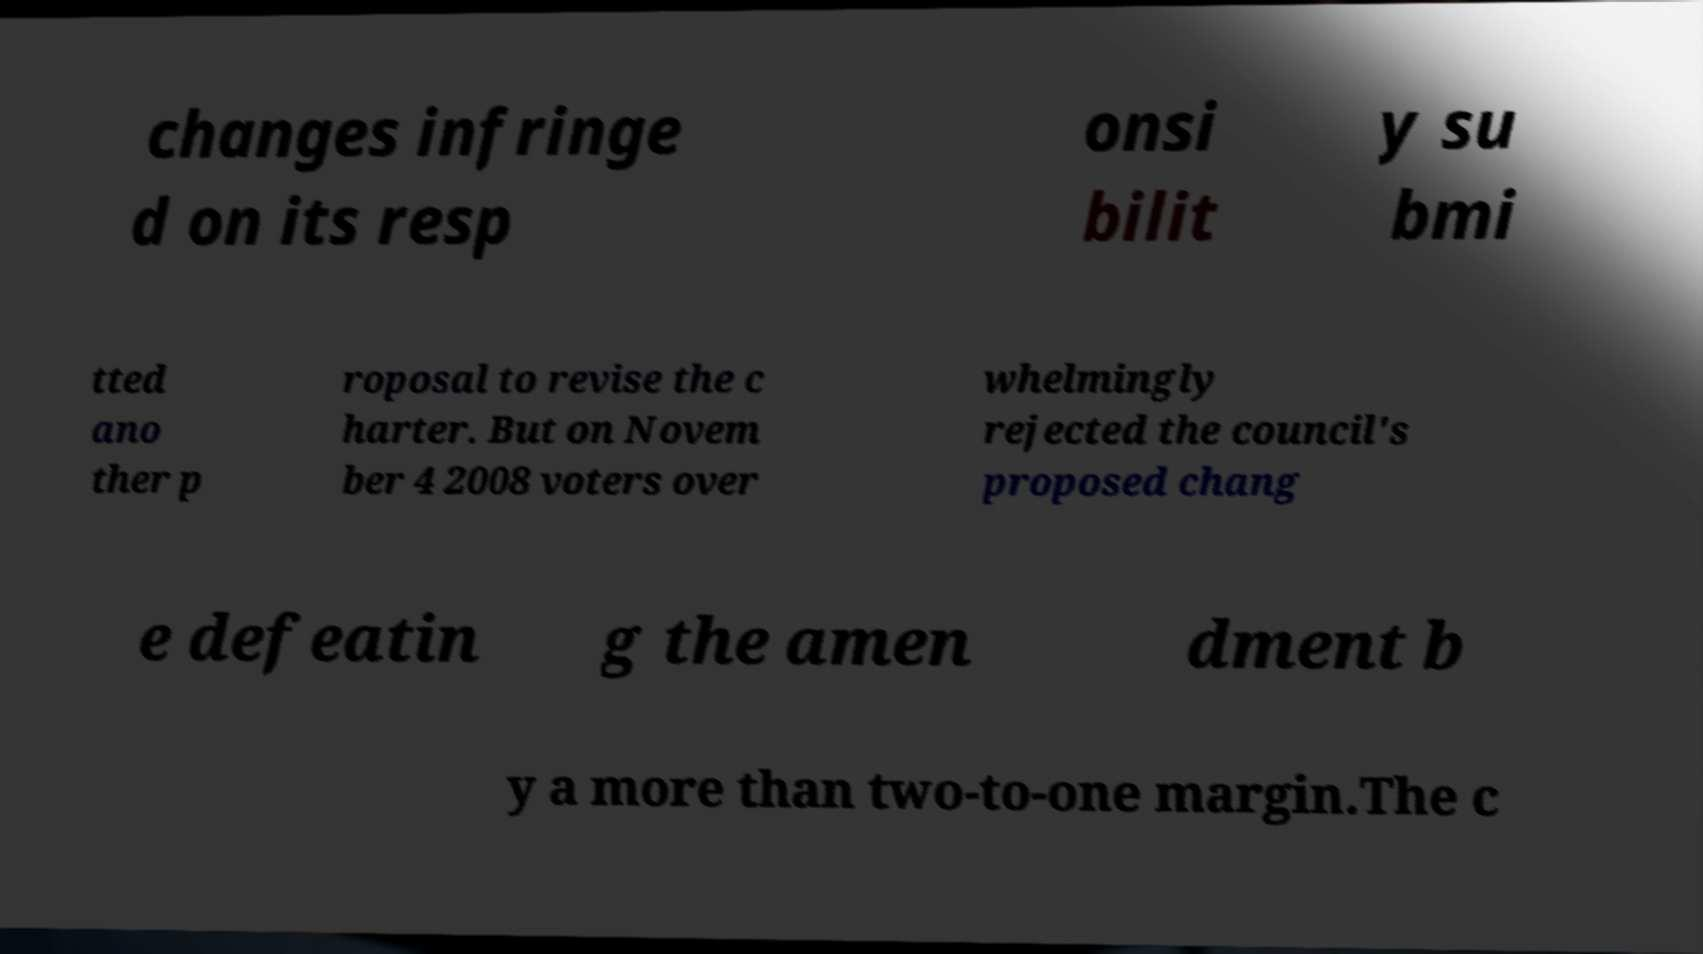Please identify and transcribe the text found in this image. changes infringe d on its resp onsi bilit y su bmi tted ano ther p roposal to revise the c harter. But on Novem ber 4 2008 voters over whelmingly rejected the council's proposed chang e defeatin g the amen dment b y a more than two-to-one margin.The c 